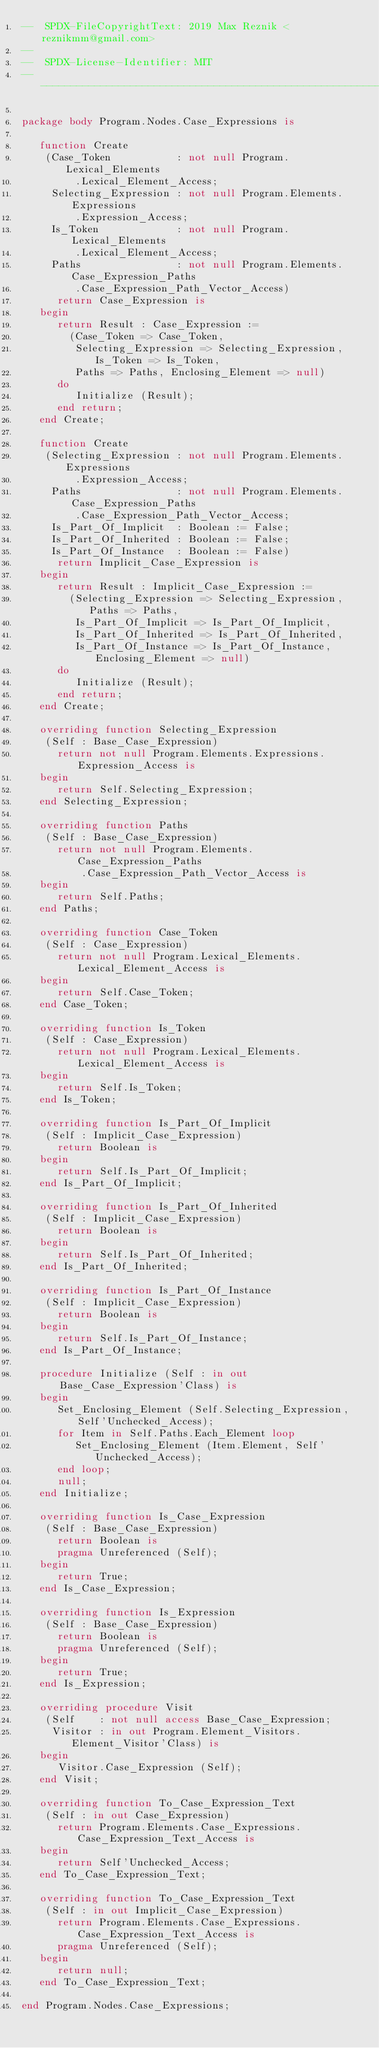<code> <loc_0><loc_0><loc_500><loc_500><_Ada_>--  SPDX-FileCopyrightText: 2019 Max Reznik <reznikmm@gmail.com>
--
--  SPDX-License-Identifier: MIT
-------------------------------------------------------------

package body Program.Nodes.Case_Expressions is

   function Create
    (Case_Token           : not null Program.Lexical_Elements
         .Lexical_Element_Access;
     Selecting_Expression : not null Program.Elements.Expressions
         .Expression_Access;
     Is_Token             : not null Program.Lexical_Elements
         .Lexical_Element_Access;
     Paths                : not null Program.Elements.Case_Expression_Paths
         .Case_Expression_Path_Vector_Access)
      return Case_Expression is
   begin
      return Result : Case_Expression :=
        (Case_Token => Case_Token,
         Selecting_Expression => Selecting_Expression, Is_Token => Is_Token,
         Paths => Paths, Enclosing_Element => null)
      do
         Initialize (Result);
      end return;
   end Create;

   function Create
    (Selecting_Expression : not null Program.Elements.Expressions
         .Expression_Access;
     Paths                : not null Program.Elements.Case_Expression_Paths
         .Case_Expression_Path_Vector_Access;
     Is_Part_Of_Implicit  : Boolean := False;
     Is_Part_Of_Inherited : Boolean := False;
     Is_Part_Of_Instance  : Boolean := False)
      return Implicit_Case_Expression is
   begin
      return Result : Implicit_Case_Expression :=
        (Selecting_Expression => Selecting_Expression, Paths => Paths,
         Is_Part_Of_Implicit => Is_Part_Of_Implicit,
         Is_Part_Of_Inherited => Is_Part_Of_Inherited,
         Is_Part_Of_Instance => Is_Part_Of_Instance, Enclosing_Element => null)
      do
         Initialize (Result);
      end return;
   end Create;

   overriding function Selecting_Expression
    (Self : Base_Case_Expression)
      return not null Program.Elements.Expressions.Expression_Access is
   begin
      return Self.Selecting_Expression;
   end Selecting_Expression;

   overriding function Paths
    (Self : Base_Case_Expression)
      return not null Program.Elements.Case_Expression_Paths
          .Case_Expression_Path_Vector_Access is
   begin
      return Self.Paths;
   end Paths;

   overriding function Case_Token
    (Self : Case_Expression)
      return not null Program.Lexical_Elements.Lexical_Element_Access is
   begin
      return Self.Case_Token;
   end Case_Token;

   overriding function Is_Token
    (Self : Case_Expression)
      return not null Program.Lexical_Elements.Lexical_Element_Access is
   begin
      return Self.Is_Token;
   end Is_Token;

   overriding function Is_Part_Of_Implicit
    (Self : Implicit_Case_Expression)
      return Boolean is
   begin
      return Self.Is_Part_Of_Implicit;
   end Is_Part_Of_Implicit;

   overriding function Is_Part_Of_Inherited
    (Self : Implicit_Case_Expression)
      return Boolean is
   begin
      return Self.Is_Part_Of_Inherited;
   end Is_Part_Of_Inherited;

   overriding function Is_Part_Of_Instance
    (Self : Implicit_Case_Expression)
      return Boolean is
   begin
      return Self.Is_Part_Of_Instance;
   end Is_Part_Of_Instance;

   procedure Initialize (Self : in out Base_Case_Expression'Class) is
   begin
      Set_Enclosing_Element (Self.Selecting_Expression, Self'Unchecked_Access);
      for Item in Self.Paths.Each_Element loop
         Set_Enclosing_Element (Item.Element, Self'Unchecked_Access);
      end loop;
      null;
   end Initialize;

   overriding function Is_Case_Expression
    (Self : Base_Case_Expression)
      return Boolean is
      pragma Unreferenced (Self);
   begin
      return True;
   end Is_Case_Expression;

   overriding function Is_Expression
    (Self : Base_Case_Expression)
      return Boolean is
      pragma Unreferenced (Self);
   begin
      return True;
   end Is_Expression;

   overriding procedure Visit
    (Self    : not null access Base_Case_Expression;
     Visitor : in out Program.Element_Visitors.Element_Visitor'Class) is
   begin
      Visitor.Case_Expression (Self);
   end Visit;

   overriding function To_Case_Expression_Text
    (Self : in out Case_Expression)
      return Program.Elements.Case_Expressions.Case_Expression_Text_Access is
   begin
      return Self'Unchecked_Access;
   end To_Case_Expression_Text;

   overriding function To_Case_Expression_Text
    (Self : in out Implicit_Case_Expression)
      return Program.Elements.Case_Expressions.Case_Expression_Text_Access is
      pragma Unreferenced (Self);
   begin
      return null;
   end To_Case_Expression_Text;

end Program.Nodes.Case_Expressions;
</code> 